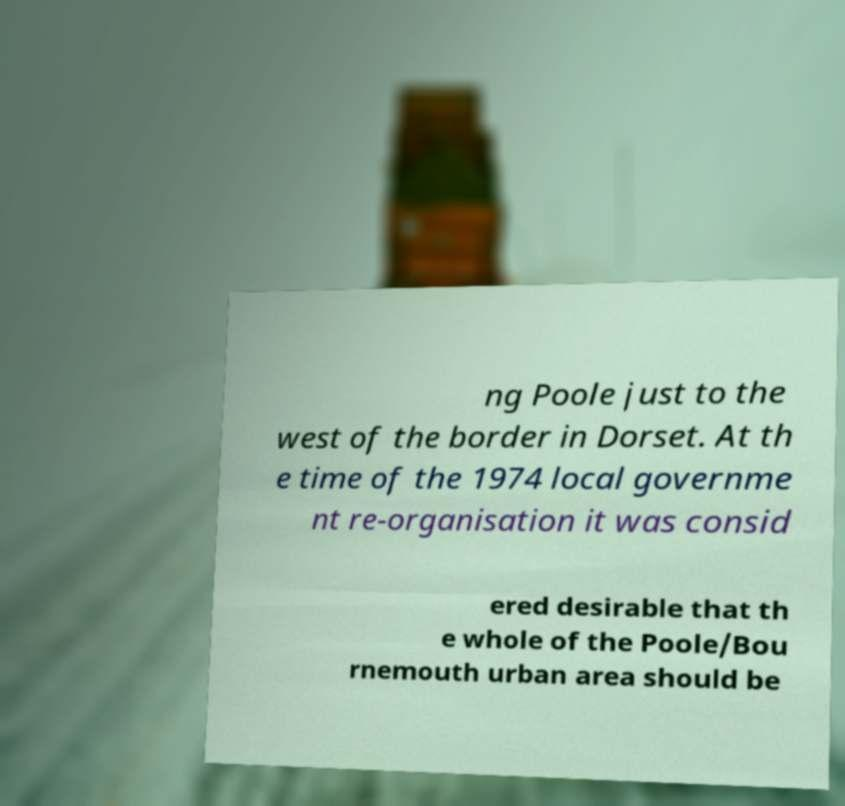There's text embedded in this image that I need extracted. Can you transcribe it verbatim? ng Poole just to the west of the border in Dorset. At th e time of the 1974 local governme nt re-organisation it was consid ered desirable that th e whole of the Poole/Bou rnemouth urban area should be 